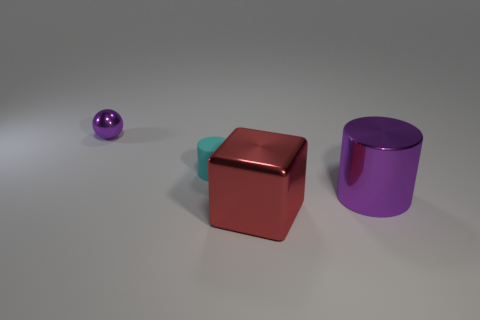Subtract all cyan balls. Subtract all brown cylinders. How many balls are left? 1 Add 2 metal cylinders. How many objects exist? 6 Subtract all spheres. How many objects are left? 3 Subtract all rubber cylinders. Subtract all purple spheres. How many objects are left? 2 Add 1 small things. How many small things are left? 3 Add 3 blue metallic cubes. How many blue metallic cubes exist? 3 Subtract 0 blue cubes. How many objects are left? 4 